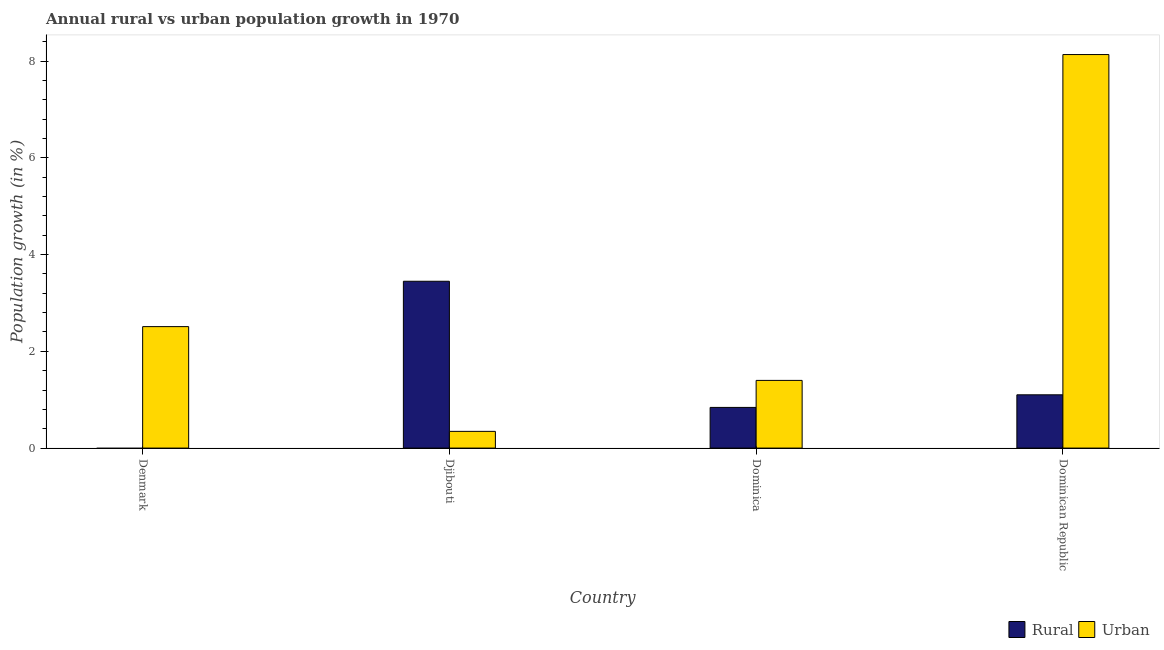Are the number of bars per tick equal to the number of legend labels?
Provide a succinct answer. No. How many bars are there on the 4th tick from the left?
Your response must be concise. 2. How many bars are there on the 1st tick from the right?
Your answer should be compact. 2. What is the label of the 3rd group of bars from the left?
Your response must be concise. Dominica. In how many cases, is the number of bars for a given country not equal to the number of legend labels?
Your answer should be very brief. 1. What is the rural population growth in Denmark?
Your answer should be compact. 0. Across all countries, what is the maximum urban population growth?
Offer a very short reply. 8.14. Across all countries, what is the minimum urban population growth?
Keep it short and to the point. 0.35. In which country was the rural population growth maximum?
Ensure brevity in your answer.  Djibouti. What is the total urban population growth in the graph?
Ensure brevity in your answer.  12.39. What is the difference between the urban population growth in Denmark and that in Dominica?
Your answer should be compact. 1.11. What is the difference between the urban population growth in Dominica and the rural population growth in Dominican Republic?
Keep it short and to the point. 0.3. What is the average rural population growth per country?
Your answer should be compact. 1.35. What is the difference between the rural population growth and urban population growth in Dominican Republic?
Offer a very short reply. -7.03. What is the ratio of the rural population growth in Djibouti to that in Dominican Republic?
Give a very brief answer. 3.13. Is the urban population growth in Djibouti less than that in Dominican Republic?
Your response must be concise. Yes. What is the difference between the highest and the second highest urban population growth?
Your answer should be very brief. 5.62. What is the difference between the highest and the lowest rural population growth?
Provide a succinct answer. 3.45. In how many countries, is the rural population growth greater than the average rural population growth taken over all countries?
Your answer should be compact. 1. How many bars are there?
Ensure brevity in your answer.  7. Are all the bars in the graph horizontal?
Keep it short and to the point. No. How many countries are there in the graph?
Provide a short and direct response. 4. What is the difference between two consecutive major ticks on the Y-axis?
Your answer should be compact. 2. Where does the legend appear in the graph?
Keep it short and to the point. Bottom right. How are the legend labels stacked?
Provide a short and direct response. Horizontal. What is the title of the graph?
Provide a short and direct response. Annual rural vs urban population growth in 1970. What is the label or title of the X-axis?
Your response must be concise. Country. What is the label or title of the Y-axis?
Offer a terse response. Population growth (in %). What is the Population growth (in %) of Urban  in Denmark?
Your answer should be very brief. 2.51. What is the Population growth (in %) of Rural in Djibouti?
Make the answer very short. 3.45. What is the Population growth (in %) of Urban  in Djibouti?
Give a very brief answer. 0.35. What is the Population growth (in %) in Rural in Dominica?
Give a very brief answer. 0.84. What is the Population growth (in %) in Urban  in Dominica?
Provide a short and direct response. 1.4. What is the Population growth (in %) in Rural in Dominican Republic?
Give a very brief answer. 1.1. What is the Population growth (in %) of Urban  in Dominican Republic?
Your answer should be compact. 8.14. Across all countries, what is the maximum Population growth (in %) in Rural?
Your response must be concise. 3.45. Across all countries, what is the maximum Population growth (in %) in Urban ?
Provide a succinct answer. 8.14. Across all countries, what is the minimum Population growth (in %) in Rural?
Give a very brief answer. 0. Across all countries, what is the minimum Population growth (in %) of Urban ?
Your response must be concise. 0.35. What is the total Population growth (in %) of Rural in the graph?
Your answer should be compact. 5.39. What is the total Population growth (in %) of Urban  in the graph?
Give a very brief answer. 12.39. What is the difference between the Population growth (in %) of Urban  in Denmark and that in Djibouti?
Provide a succinct answer. 2.17. What is the difference between the Population growth (in %) of Urban  in Denmark and that in Dominica?
Make the answer very short. 1.11. What is the difference between the Population growth (in %) of Urban  in Denmark and that in Dominican Republic?
Provide a short and direct response. -5.62. What is the difference between the Population growth (in %) of Rural in Djibouti and that in Dominica?
Your response must be concise. 2.61. What is the difference between the Population growth (in %) of Urban  in Djibouti and that in Dominica?
Keep it short and to the point. -1.05. What is the difference between the Population growth (in %) in Rural in Djibouti and that in Dominican Republic?
Provide a succinct answer. 2.35. What is the difference between the Population growth (in %) of Urban  in Djibouti and that in Dominican Republic?
Give a very brief answer. -7.79. What is the difference between the Population growth (in %) of Rural in Dominica and that in Dominican Republic?
Keep it short and to the point. -0.26. What is the difference between the Population growth (in %) of Urban  in Dominica and that in Dominican Republic?
Your response must be concise. -6.74. What is the difference between the Population growth (in %) of Rural in Djibouti and the Population growth (in %) of Urban  in Dominica?
Provide a short and direct response. 2.05. What is the difference between the Population growth (in %) of Rural in Djibouti and the Population growth (in %) of Urban  in Dominican Republic?
Offer a very short reply. -4.69. What is the difference between the Population growth (in %) in Rural in Dominica and the Population growth (in %) in Urban  in Dominican Republic?
Offer a very short reply. -7.29. What is the average Population growth (in %) in Rural per country?
Provide a short and direct response. 1.35. What is the average Population growth (in %) in Urban  per country?
Your answer should be compact. 3.1. What is the difference between the Population growth (in %) of Rural and Population growth (in %) of Urban  in Djibouti?
Offer a terse response. 3.1. What is the difference between the Population growth (in %) in Rural and Population growth (in %) in Urban  in Dominica?
Your response must be concise. -0.56. What is the difference between the Population growth (in %) in Rural and Population growth (in %) in Urban  in Dominican Republic?
Give a very brief answer. -7.03. What is the ratio of the Population growth (in %) in Urban  in Denmark to that in Djibouti?
Provide a succinct answer. 7.26. What is the ratio of the Population growth (in %) in Urban  in Denmark to that in Dominica?
Your answer should be compact. 1.79. What is the ratio of the Population growth (in %) of Urban  in Denmark to that in Dominican Republic?
Make the answer very short. 0.31. What is the ratio of the Population growth (in %) in Rural in Djibouti to that in Dominica?
Keep it short and to the point. 4.1. What is the ratio of the Population growth (in %) in Urban  in Djibouti to that in Dominica?
Your answer should be compact. 0.25. What is the ratio of the Population growth (in %) of Rural in Djibouti to that in Dominican Republic?
Provide a short and direct response. 3.13. What is the ratio of the Population growth (in %) of Urban  in Djibouti to that in Dominican Republic?
Your answer should be very brief. 0.04. What is the ratio of the Population growth (in %) in Rural in Dominica to that in Dominican Republic?
Your answer should be very brief. 0.76. What is the ratio of the Population growth (in %) of Urban  in Dominica to that in Dominican Republic?
Keep it short and to the point. 0.17. What is the difference between the highest and the second highest Population growth (in %) of Rural?
Your answer should be very brief. 2.35. What is the difference between the highest and the second highest Population growth (in %) in Urban ?
Provide a succinct answer. 5.62. What is the difference between the highest and the lowest Population growth (in %) in Rural?
Your response must be concise. 3.45. What is the difference between the highest and the lowest Population growth (in %) of Urban ?
Offer a very short reply. 7.79. 